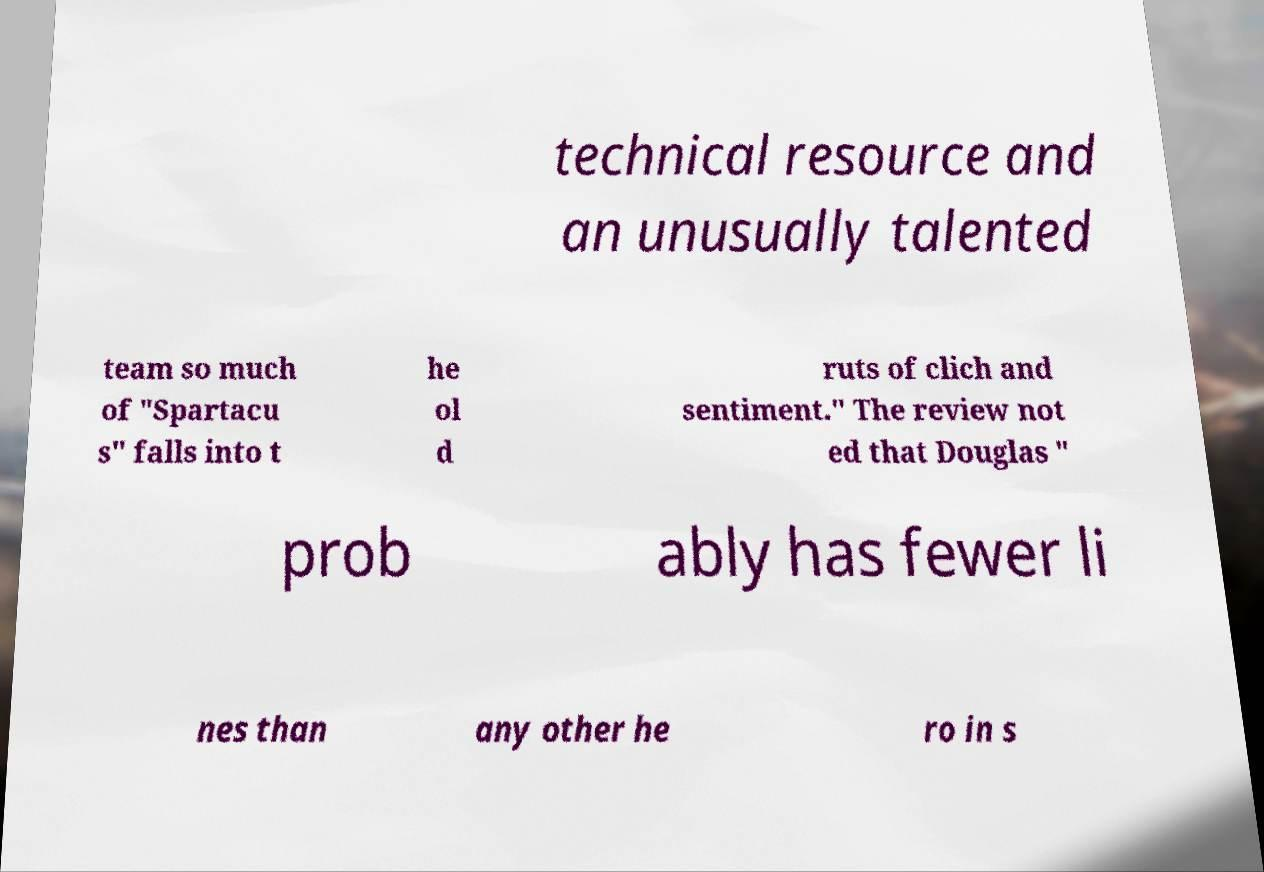Please read and relay the text visible in this image. What does it say? technical resource and an unusually talented team so much of "Spartacu s" falls into t he ol d ruts of clich and sentiment." The review not ed that Douglas " prob ably has fewer li nes than any other he ro in s 